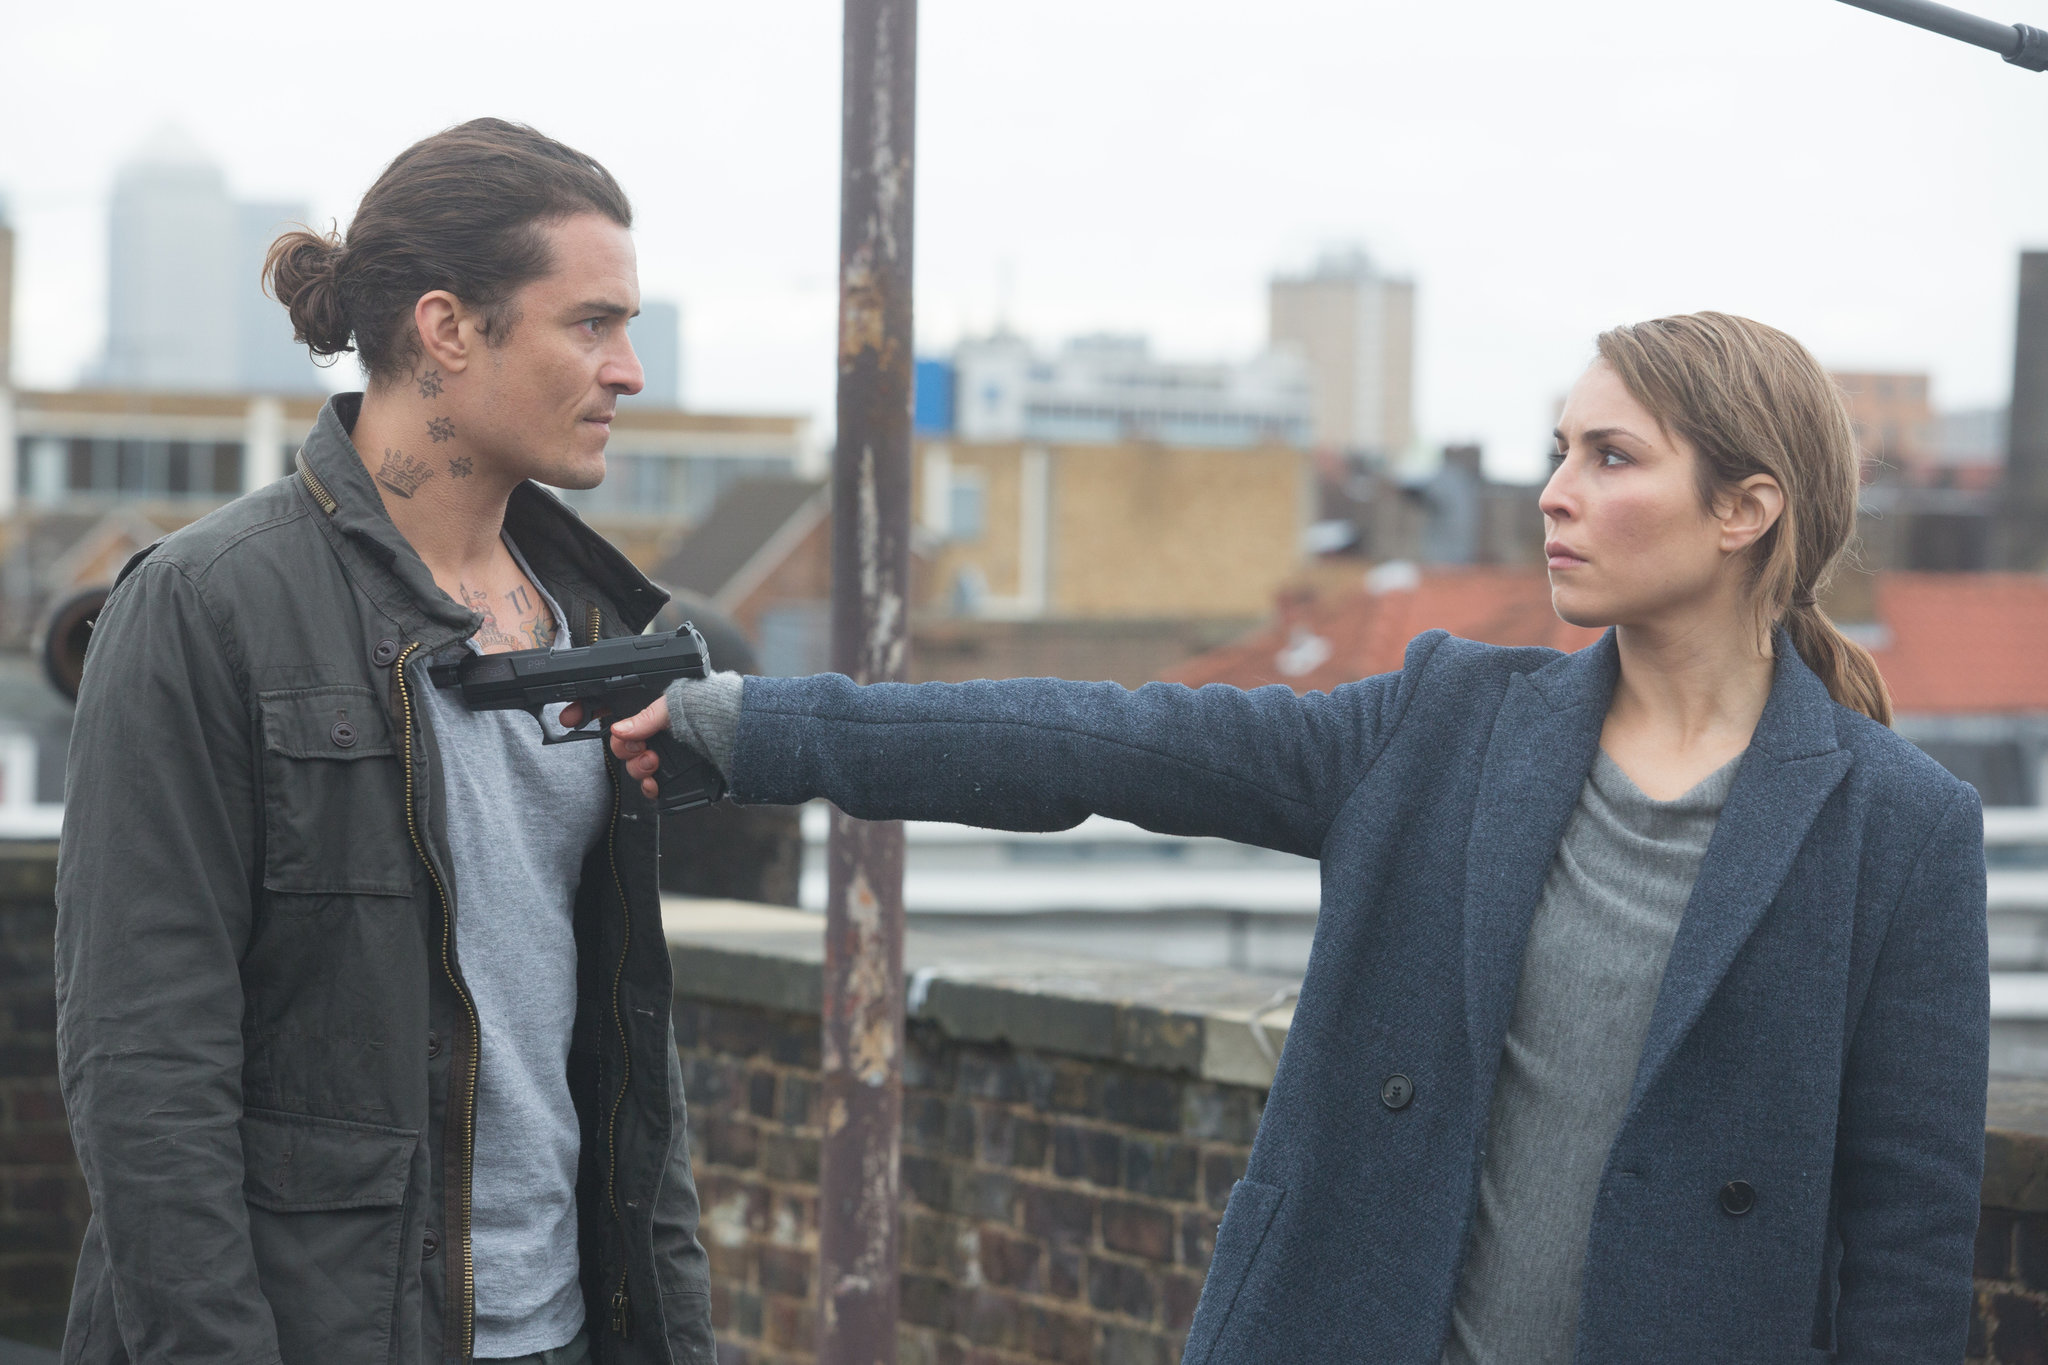Can you explain the emotions of the characters in this image? In this image, the character played by Noomi Rapace, who seems to be named sharegpt4v/sam, exudes determination and focus as she points a gun at the man in front of her. Her steadfast expression shows that she is in control of the situation and is prepared to take action if necessary. The man, identifiable by his tattoos and green jacket, appears remarkably calm considering the circumstances, indicating either resignation or immense confidence. The tension between their opposing emotions heightens the drama of the scene. Do you think this might be a critical moment in the storyline? Absolutely, this image is likely capturing a pivotal moment in the storyline. The high-stakes confrontation on the rooftop, combined with the intense expressions and the urban setting, suggests that significant plot developments are at play. Such moments typically occur when key decisions are made or major conflicts are resolved, potentially altering the course of the story dramatically. What could be the stakes involved in this scene? The stakes in this scene seem very high, considering the presence of a gun and the intense expressions of the characters. It is possible that the confrontation involves a life-or-death situation, personal vendettas, or crucial information that could impact the story's outcome. sharegpt4v/sam’s serious demeanor and determination suggest she is highly motivated by critical stakes, be it saving a life, exacting revenge, or securing important intel. The man's calm attitude might imply he holds valuable secrets or is attempting to negotiate his way out of a dire situation. 